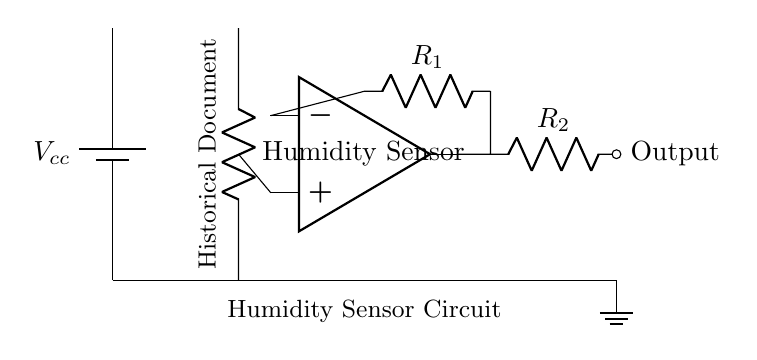What type of sensor is used in this circuit? The circuit includes a humidity sensor as indicated by the label. It is the component that measures humidity levels.
Answer: Humidity Sensor What do the two resistors in the circuit represent? The resistors labeled R1 and R2 are components used in the op-amp feedback and output stage, respectively, affecting gain and signal processing.
Answer: R1 and R2 Which component is responsible for signal amplification? The operational amplifier (op-amp) is responsible for amplifying the electrical signal from the humidity sensor to a noticeable level.
Answer: Op-amp What is the power supply voltage noted in the circuit? The circuit uses a battery as a power source, labeled as Vcc, but the exact voltage value is not specified in the diagram. Therefore, it can be inferred to be a standard voltage for such circuits, commonly five volts.
Answer: Vcc (common value: five volts) Where is the output signal taken from in the circuit? The output signal is taken from the output of the op-amp, specifically from the terminal connected to resistor R2.
Answer: Output at op-amp What is the significance of grounding in this circuit? Grounding provides a reference point for the circuit's voltages and ensures safety by preventing excess voltage buildup that could damage components.
Answer: Safety and voltage reference What does the label "Historical Document" indicate in this circuit? The label signifies that the purpose of the circuit is to monitor the humidity environment of historical documents, ensuring their preservation.
Answer: Monitoring environment for preservation 